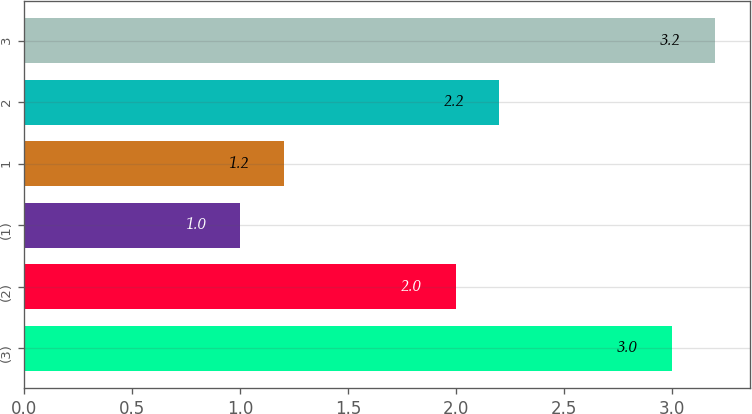Convert chart to OTSL. <chart><loc_0><loc_0><loc_500><loc_500><bar_chart><fcel>(3)<fcel>(2)<fcel>(1)<fcel>1<fcel>2<fcel>3<nl><fcel>3<fcel>2<fcel>1<fcel>1.2<fcel>2.2<fcel>3.2<nl></chart> 